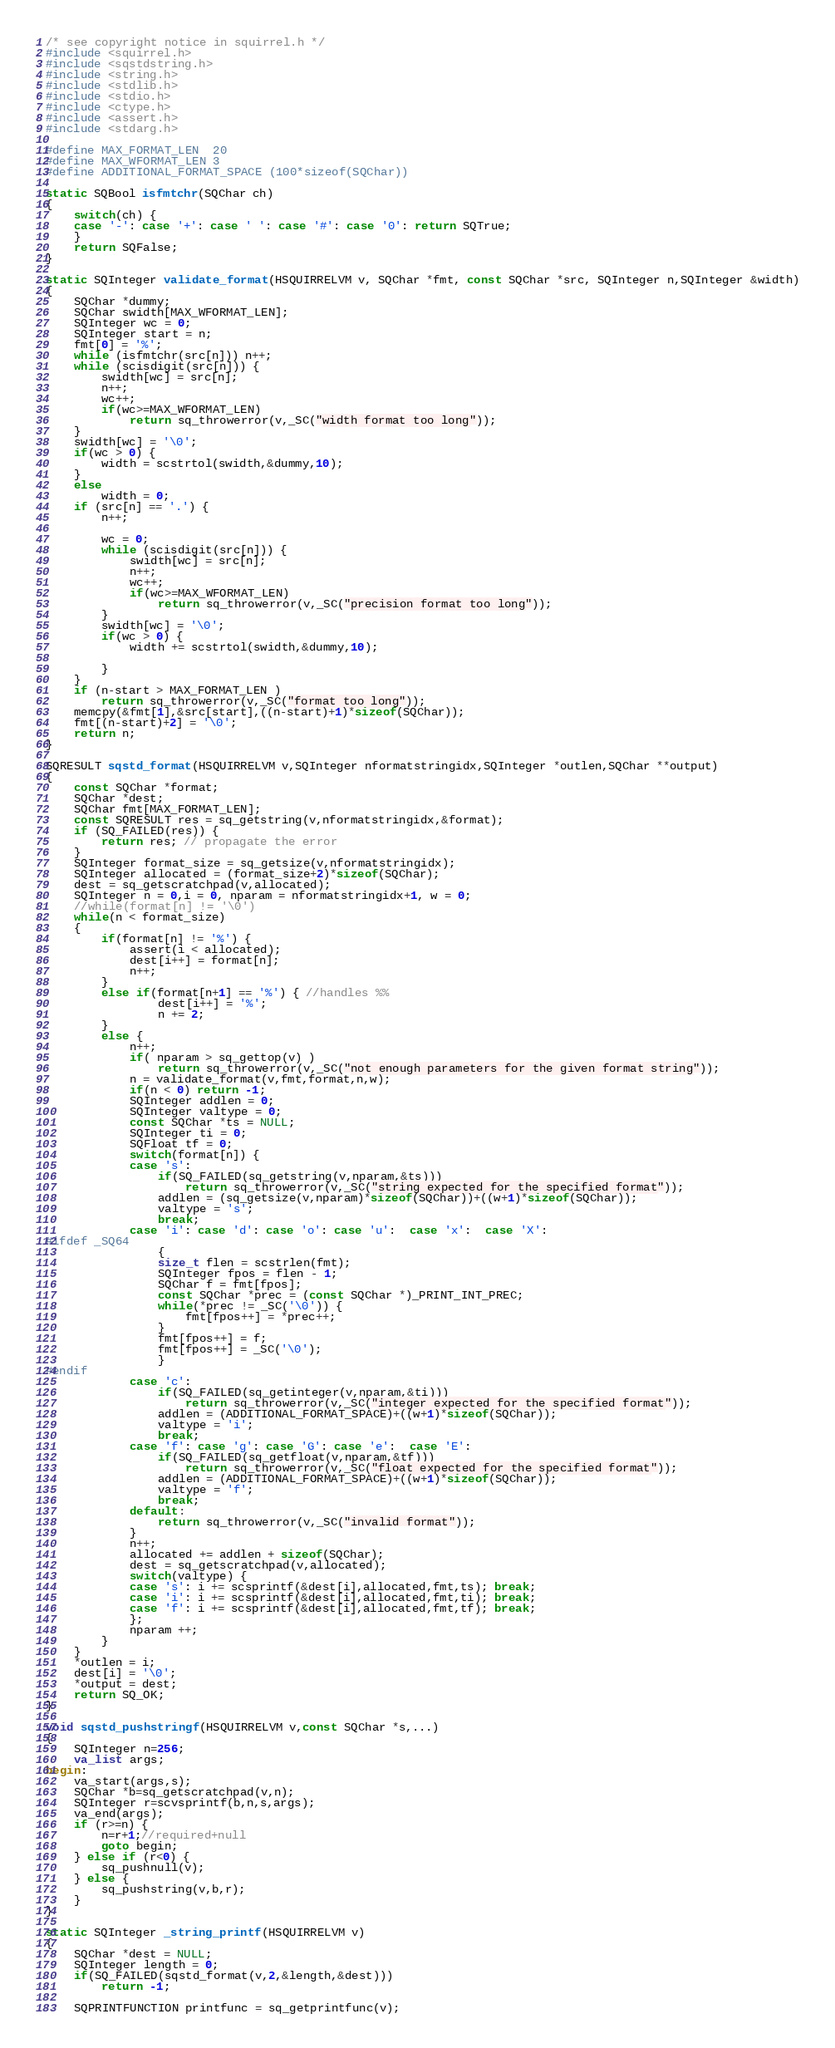<code> <loc_0><loc_0><loc_500><loc_500><_C++_>/* see copyright notice in squirrel.h */
#include <squirrel.h>
#include <sqstdstring.h>
#include <string.h>
#include <stdlib.h>
#include <stdio.h>
#include <ctype.h>
#include <assert.h>
#include <stdarg.h>

#define MAX_FORMAT_LEN  20
#define MAX_WFORMAT_LEN 3
#define ADDITIONAL_FORMAT_SPACE (100*sizeof(SQChar))

static SQBool isfmtchr(SQChar ch)
{
    switch(ch) {
    case '-': case '+': case ' ': case '#': case '0': return SQTrue;
    }
    return SQFalse;
}

static SQInteger validate_format(HSQUIRRELVM v, SQChar *fmt, const SQChar *src, SQInteger n,SQInteger &width)
{
    SQChar *dummy;
    SQChar swidth[MAX_WFORMAT_LEN];
    SQInteger wc = 0;
    SQInteger start = n;
    fmt[0] = '%';
    while (isfmtchr(src[n])) n++;
    while (scisdigit(src[n])) {
        swidth[wc] = src[n];
        n++;
        wc++;
        if(wc>=MAX_WFORMAT_LEN)
            return sq_throwerror(v,_SC("width format too long"));
    }
    swidth[wc] = '\0';
    if(wc > 0) {
        width = scstrtol(swidth,&dummy,10);
    }
    else
        width = 0;
    if (src[n] == '.') {
        n++;

        wc = 0;
        while (scisdigit(src[n])) {
            swidth[wc] = src[n];
            n++;
            wc++;
            if(wc>=MAX_WFORMAT_LEN)
                return sq_throwerror(v,_SC("precision format too long"));
        }
        swidth[wc] = '\0';
        if(wc > 0) {
            width += scstrtol(swidth,&dummy,10);

        }
    }
    if (n-start > MAX_FORMAT_LEN )
        return sq_throwerror(v,_SC("format too long"));
    memcpy(&fmt[1],&src[start],((n-start)+1)*sizeof(SQChar));
    fmt[(n-start)+2] = '\0';
    return n;
}

SQRESULT sqstd_format(HSQUIRRELVM v,SQInteger nformatstringidx,SQInteger *outlen,SQChar **output)
{
    const SQChar *format;
    SQChar *dest;
    SQChar fmt[MAX_FORMAT_LEN];
    const SQRESULT res = sq_getstring(v,nformatstringidx,&format);
    if (SQ_FAILED(res)) {
        return res; // propagate the error
    }
    SQInteger format_size = sq_getsize(v,nformatstringidx);
    SQInteger allocated = (format_size+2)*sizeof(SQChar);
    dest = sq_getscratchpad(v,allocated);
    SQInteger n = 0,i = 0, nparam = nformatstringidx+1, w = 0;
    //while(format[n] != '\0')
    while(n < format_size)
    {
        if(format[n] != '%') {
            assert(i < allocated);
            dest[i++] = format[n];
            n++;
        }
        else if(format[n+1] == '%') { //handles %%
                dest[i++] = '%';
                n += 2;
        }
        else {
            n++;
            if( nparam > sq_gettop(v) )
                return sq_throwerror(v,_SC("not enough parameters for the given format string"));
            n = validate_format(v,fmt,format,n,w);
            if(n < 0) return -1;
            SQInteger addlen = 0;
            SQInteger valtype = 0;
            const SQChar *ts = NULL;
            SQInteger ti = 0;
            SQFloat tf = 0;
            switch(format[n]) {
            case 's':
                if(SQ_FAILED(sq_getstring(v,nparam,&ts)))
                    return sq_throwerror(v,_SC("string expected for the specified format"));
                addlen = (sq_getsize(v,nparam)*sizeof(SQChar))+((w+1)*sizeof(SQChar));
                valtype = 's';
                break;
            case 'i': case 'd': case 'o': case 'u':  case 'x':  case 'X':
#ifdef _SQ64
                {
                size_t flen = scstrlen(fmt);
                SQInteger fpos = flen - 1;
                SQChar f = fmt[fpos];
                const SQChar *prec = (const SQChar *)_PRINT_INT_PREC;
                while(*prec != _SC('\0')) {
                    fmt[fpos++] = *prec++;
                }
                fmt[fpos++] = f;
                fmt[fpos++] = _SC('\0');
                }
#endif
            case 'c':
                if(SQ_FAILED(sq_getinteger(v,nparam,&ti)))
                    return sq_throwerror(v,_SC("integer expected for the specified format"));
                addlen = (ADDITIONAL_FORMAT_SPACE)+((w+1)*sizeof(SQChar));
                valtype = 'i';
                break;
            case 'f': case 'g': case 'G': case 'e':  case 'E':
                if(SQ_FAILED(sq_getfloat(v,nparam,&tf)))
                    return sq_throwerror(v,_SC("float expected for the specified format"));
                addlen = (ADDITIONAL_FORMAT_SPACE)+((w+1)*sizeof(SQChar));
                valtype = 'f';
                break;
            default:
                return sq_throwerror(v,_SC("invalid format"));
            }
            n++;
            allocated += addlen + sizeof(SQChar);
            dest = sq_getscratchpad(v,allocated);
            switch(valtype) {
            case 's': i += scsprintf(&dest[i],allocated,fmt,ts); break;
            case 'i': i += scsprintf(&dest[i],allocated,fmt,ti); break;
            case 'f': i += scsprintf(&dest[i],allocated,fmt,tf); break;
            };
            nparam ++;
        }
    }
    *outlen = i;
    dest[i] = '\0';
    *output = dest;
    return SQ_OK;
}

void sqstd_pushstringf(HSQUIRRELVM v,const SQChar *s,...)
{
    SQInteger n=256;
    va_list args;
begin:
    va_start(args,s);
    SQChar *b=sq_getscratchpad(v,n);
    SQInteger r=scvsprintf(b,n,s,args);
    va_end(args);
    if (r>=n) {
        n=r+1;//required+null
        goto begin;
    } else if (r<0) {
        sq_pushnull(v);
    } else {
        sq_pushstring(v,b,r);
    }
}

static SQInteger _string_printf(HSQUIRRELVM v)
{
    SQChar *dest = NULL;
    SQInteger length = 0;
    if(SQ_FAILED(sqstd_format(v,2,&length,&dest)))
        return -1;

    SQPRINTFUNCTION printfunc = sq_getprintfunc(v);</code> 